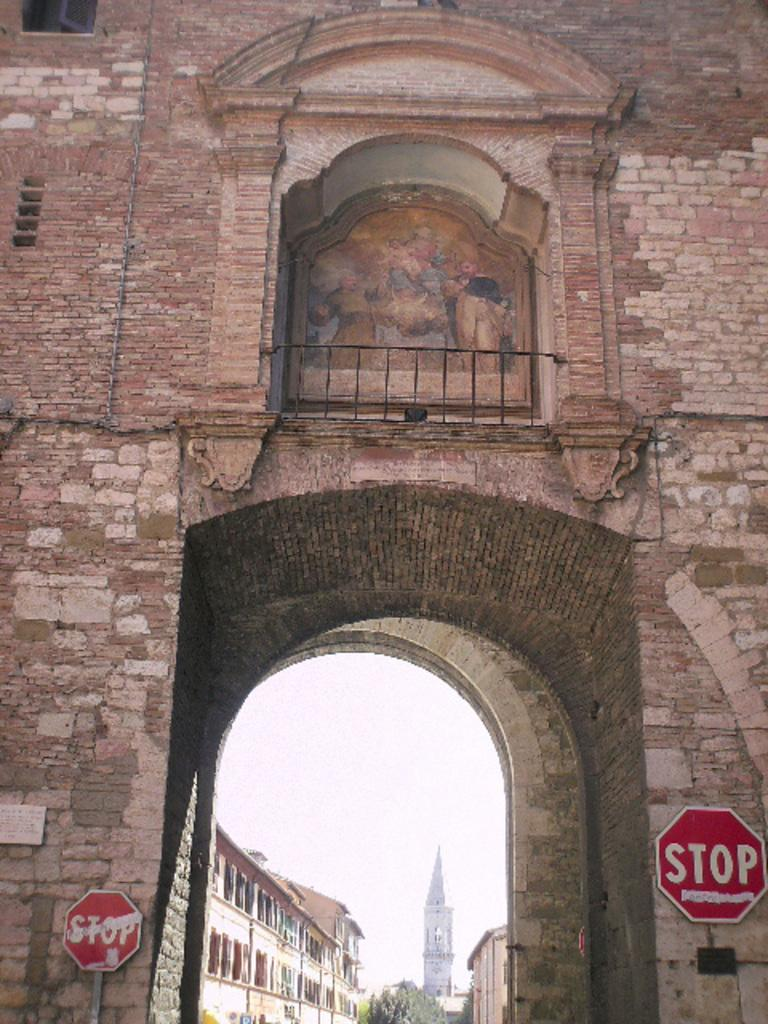What type of structure can be seen in the image? There is a wall with an iron grille in the image. What architectural feature is present in the image? There is an arch in the image. What is located at the bottom of the image? Sign boards, buildings, and trees are present at the bottom of the image. What part of the natural environment is visible in the image? The sky is visible in the image. How much debt is the goat carrying in the image? There is no goat present in the image, and therefore no debt can be associated with it. What type of sail is visible on the wall in the image? There is no sail present in the image; it features a wall with an iron grille and an arch. 